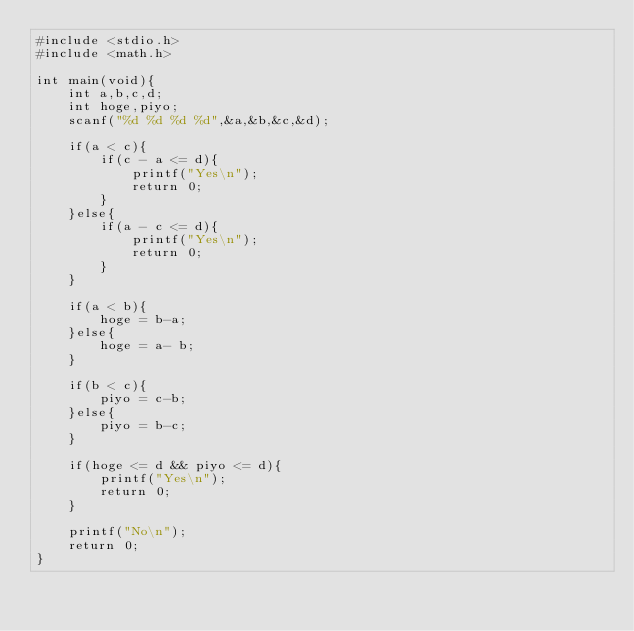Convert code to text. <code><loc_0><loc_0><loc_500><loc_500><_C_>#include <stdio.h>
#include <math.h>
 
int main(void){
	int a,b,c,d;
	int hoge,piyo;
	scanf("%d %d %d %d",&a,&b,&c,&d);
	
	if(a < c){
		if(c - a <= d){
			printf("Yes\n");
			return 0;
		}
	}else{
		if(a - c <= d){
			printf("Yes\n");
			return 0;
		}
	}

	if(a < b){
		hoge = b-a;
	}else{
		hoge = a- b;
	}

	if(b < c){
		piyo = c-b;
	}else{
		piyo = b-c;
	}	

	if(hoge <= d && piyo <= d){
		printf("Yes\n");
		return 0;
	}

	printf("No\n");
	return 0;
}</code> 